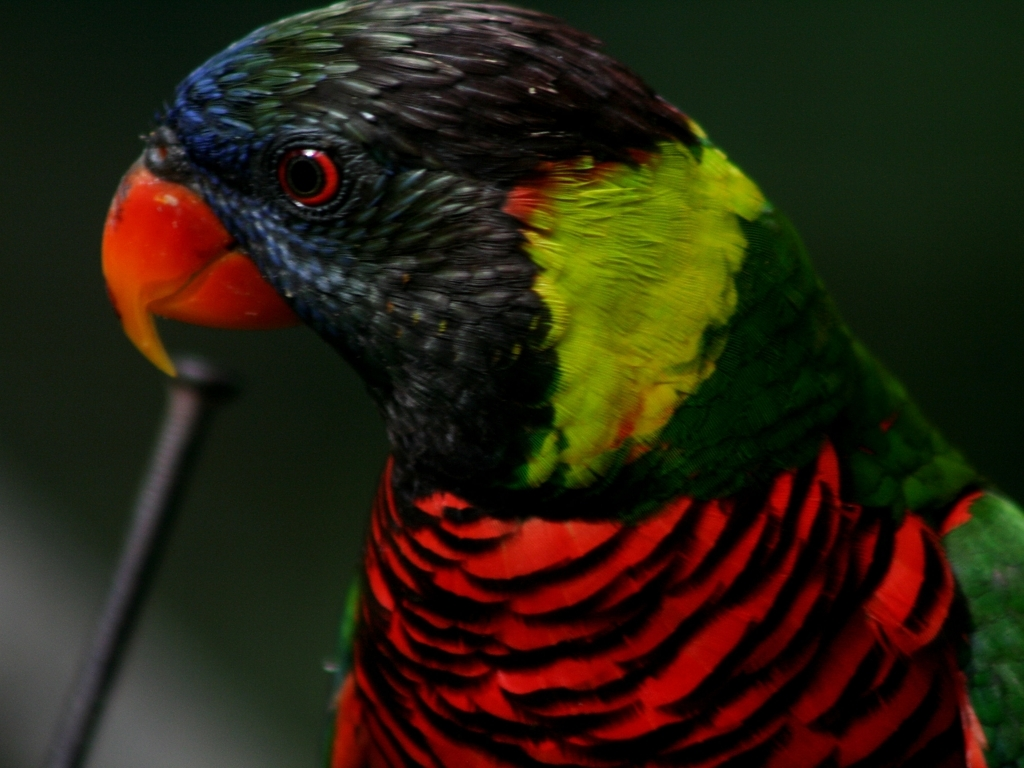What is the natural habitat of the parrot in this image? The natural habitat of the Rainbow Lorikeet includes coastal bushland, rainforest regions, and woodland areas in Australia and the eastern Indonesia region. They thrive in environments where flowering trees are abundant, providing them with the nectar and pollen that make up their diet. 